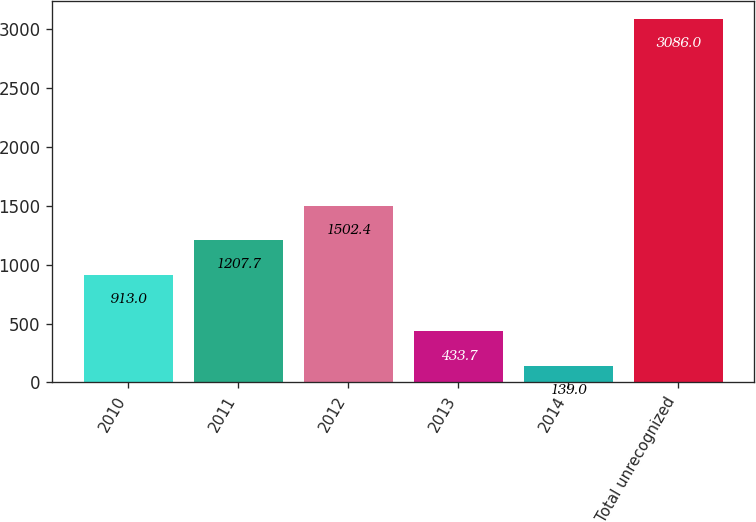Convert chart. <chart><loc_0><loc_0><loc_500><loc_500><bar_chart><fcel>2010<fcel>2011<fcel>2012<fcel>2013<fcel>2014<fcel>Total unrecognized<nl><fcel>913<fcel>1207.7<fcel>1502.4<fcel>433.7<fcel>139<fcel>3086<nl></chart> 